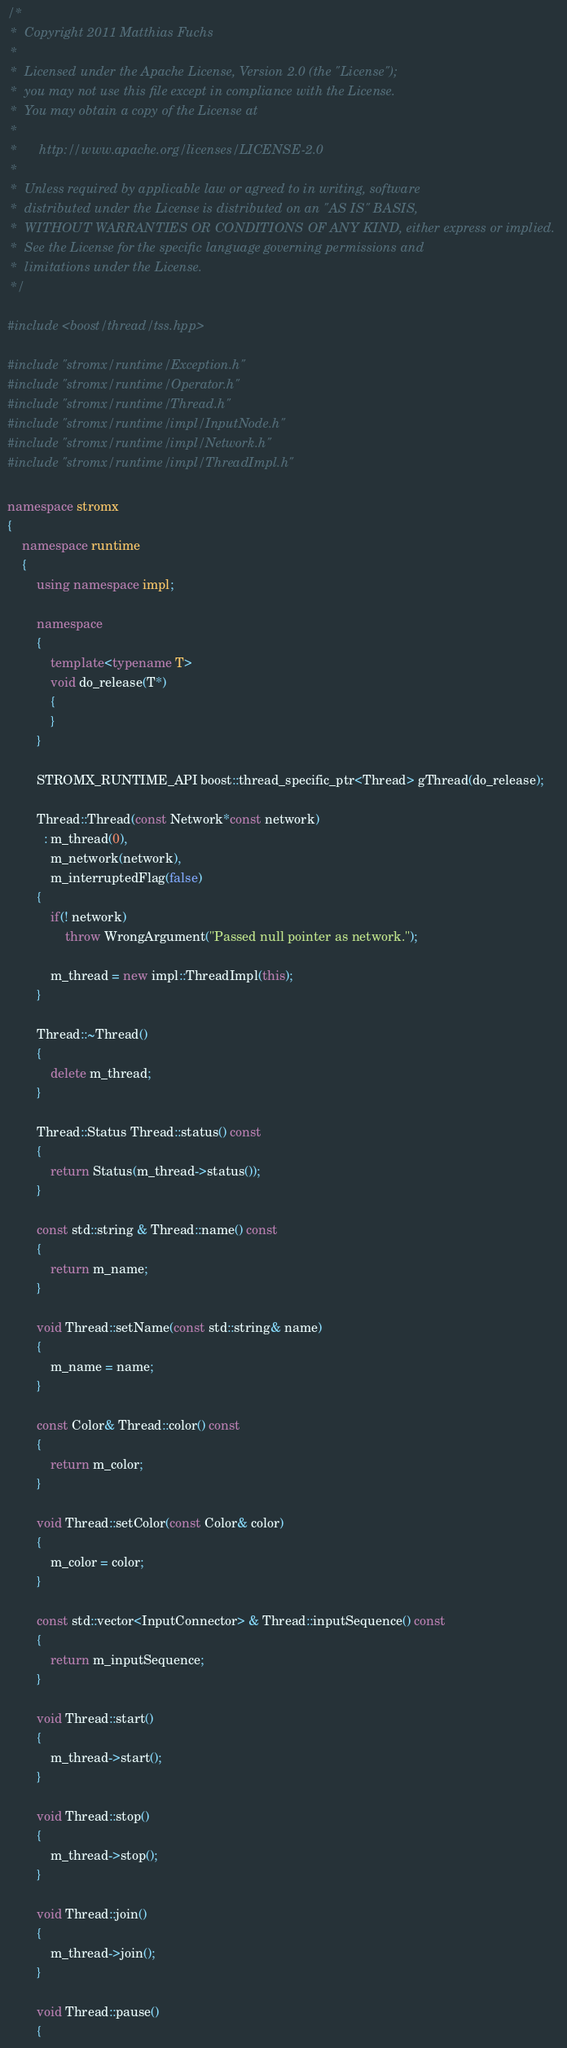<code> <loc_0><loc_0><loc_500><loc_500><_C++_>/* 
 *  Copyright 2011 Matthias Fuchs
 *
 *  Licensed under the Apache License, Version 2.0 (the "License");
 *  you may not use this file except in compliance with the License.
 *  You may obtain a copy of the License at
 *
 *      http://www.apache.org/licenses/LICENSE-2.0
 *
 *  Unless required by applicable law or agreed to in writing, software
 *  distributed under the License is distributed on an "AS IS" BASIS,
 *  WITHOUT WARRANTIES OR CONDITIONS OF ANY KIND, either express or implied.
 *  See the License for the specific language governing permissions and
 *  limitations under the License.
 */

#include <boost/thread/tss.hpp>

#include "stromx/runtime/Exception.h"
#include "stromx/runtime/Operator.h"
#include "stromx/runtime/Thread.h"
#include "stromx/runtime/impl/InputNode.h"
#include "stromx/runtime/impl/Network.h"
#include "stromx/runtime/impl/ThreadImpl.h"

namespace stromx
{
    namespace runtime
    {
        using namespace impl;
        
        namespace 
        {
            template<typename T>
            void do_release(T*)
            {
            }
        }
        
        STROMX_RUNTIME_API boost::thread_specific_ptr<Thread> gThread(do_release);
        
        Thread::Thread(const Network*const network)
          : m_thread(0),
            m_network(network),
            m_interruptedFlag(false)
        {
            if(! network)
                throw WrongArgument("Passed null pointer as network.");
            
            m_thread = new impl::ThreadImpl(this);
        }
        
        Thread::~Thread()
        {
            delete m_thread;
        }
        
        Thread::Status Thread::status() const 
        { 
            return Status(m_thread->status());
        }
        
        const std::string & Thread::name() const
        {
            return m_name; 
        }
        
        void Thread::setName(const std::string& name)
        { 
            m_name = name; 
        }
        
        const Color& Thread::color() const
        {
            return m_color;
        }

        void Thread::setColor(const Color& color)
        {
            m_color = color;
        }
        
        const std::vector<InputConnector> & Thread::inputSequence() const
        { 
            return m_inputSequence;
        }
        
        void Thread::start()
        {
            m_thread->start();
        }
        
        void Thread::stop()
        {
            m_thread->stop(); 
        }
        
        void Thread::join()
        { 
            m_thread->join();
        }
        
        void Thread::pause()
        {</code> 